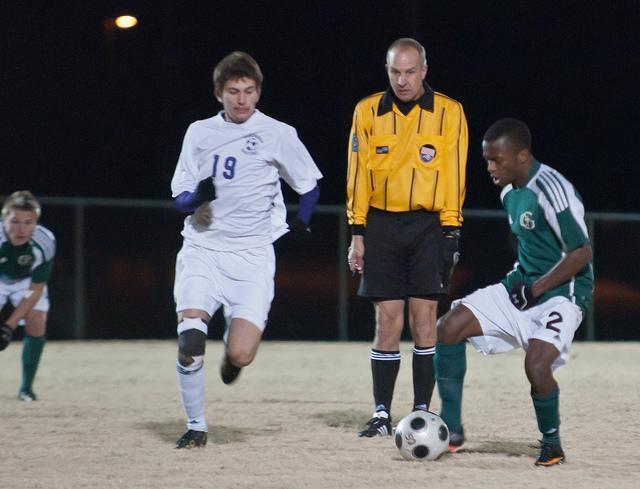How many people can you see?
Give a very brief answer. 4. 